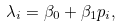Convert formula to latex. <formula><loc_0><loc_0><loc_500><loc_500>\lambda _ { i } = \beta _ { 0 } + \beta _ { 1 } p _ { i } ,</formula> 